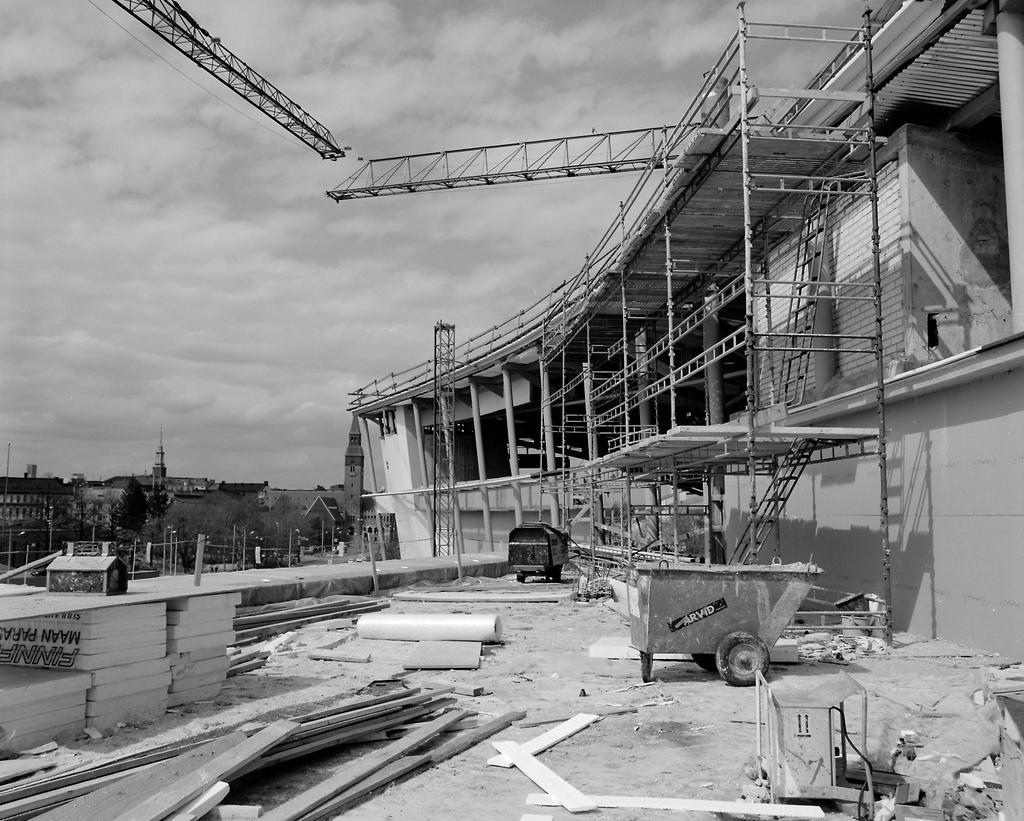How would you summarize this image in a sentence or two? In this image we can see a cloudy sky, crane towers, rods, poles, trees, vehicle, cart, walls and things.  